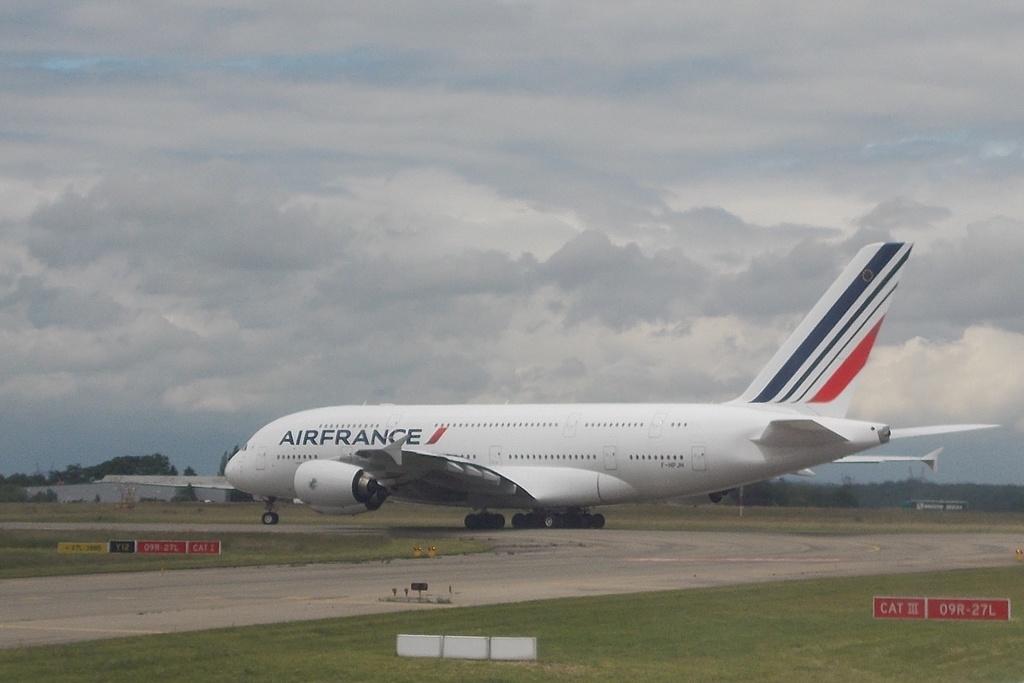What airline is this?
Ensure brevity in your answer.  Airfrance. 